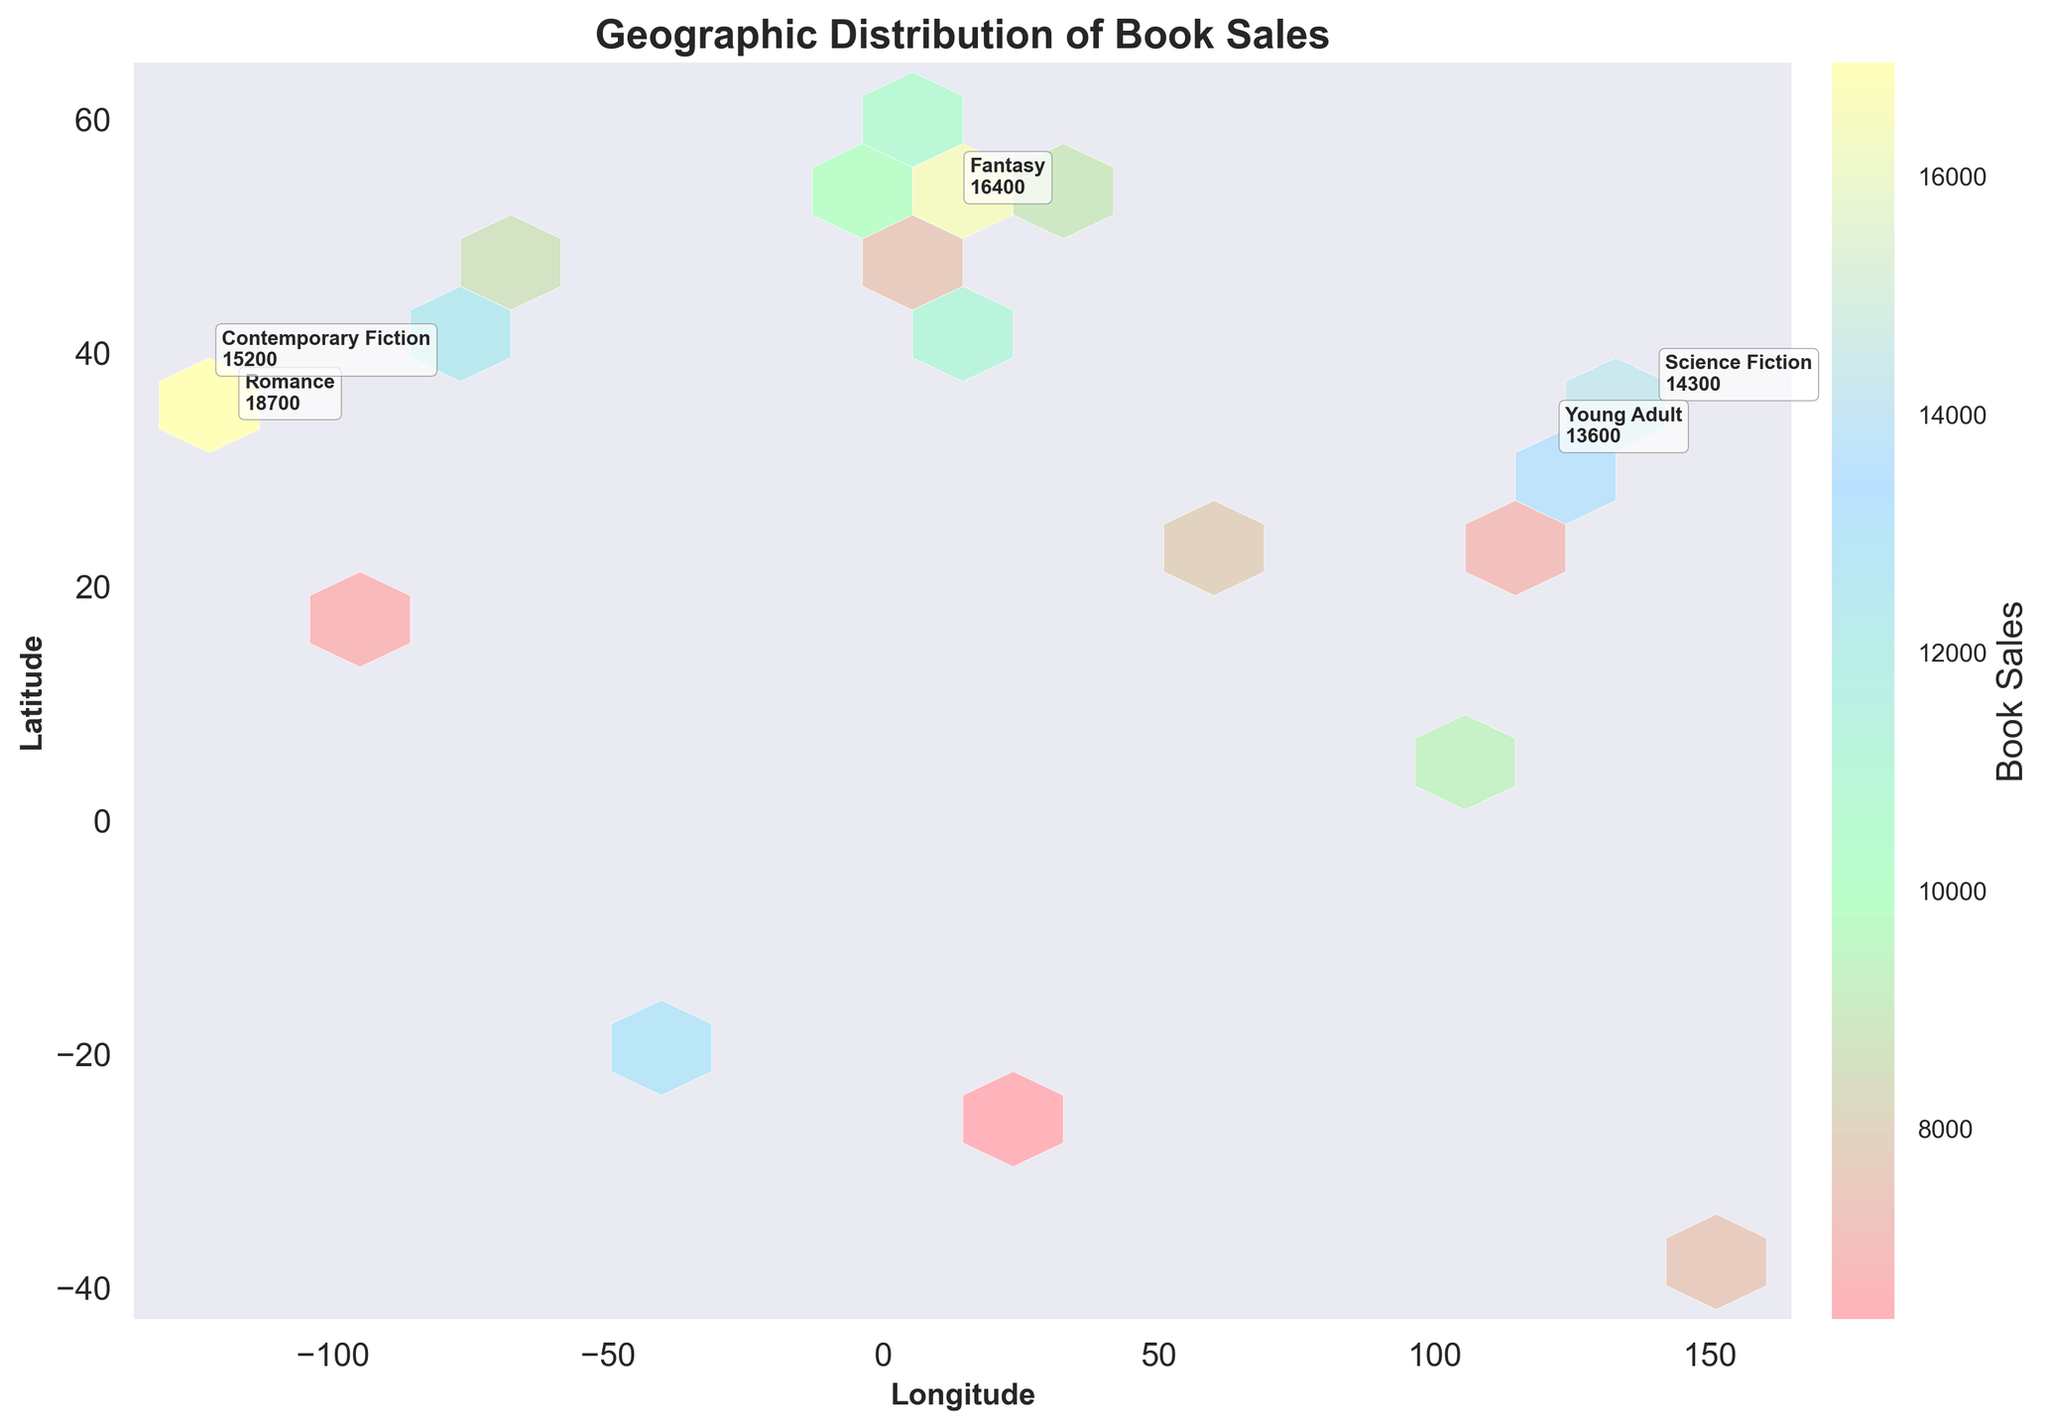1. What is the title of the plot? The title is usually found at the top of the plot, summarizing its content.
Answer: Geographic Distribution of Book Sales 2. How are the axes labeled? The x-axis and y-axis labels are "Longitude" and "Latitude," respectively, indicating the geographical coordinates of the data points.
Answer: Longitude, Latitude 3. How many genres are annotated in the plot? There are 5 data points that are highlighted with text annotations, usually shown with a label next to the data points.
Answer: 5 4. Which genre has the highest book sales, and what are those sales? By looking at the text annotations, find the one with the highest sales value. The highest value is typically the one with the largest number.
Answer: Romance, 18700 5. Which city has the coordinates closest to (40, -74) and what genre is popular there? Identify the annotations closest to the given coordinates and read the corresponding genre. 40.7128° N, 74.0060° W closely matches New York City, which has a Mystery genre.
Answer: Mystery 6. What is the color indicating the highest book sale on the color bar? Look at the color bar, which shows the gradient associated with the value of book sales. The color at the top end of the gradient represents the highest sales.
Answer: Pink 7. Compare the book sales of Science Fiction and Thriller. Which one has higher sales? Refer to the text annotations for Science Fiction (in Tokyo) and Thriller (in Rome). Compare their sales values.
Answer: Science Fiction 8. What's the combined book sales for the top 2 genres? The top 2 sales values are 18700 (Romance) and 16400 (Fantasy). Sum these values. 18700 + 16400 = 35100
Answer: 35100 9. What is the difference in book sales between Historical Fiction and Poetry? Find the sales values of both genres, Historical Fiction (9800) and Poetry (5200). Subtract the smaller value from the larger one to find the difference. 9800 - 5200 = 4600
Answer: 4600 10. How does book sales distribution look geographically around longitudes -74 and -118? Look at the hexagons close to these longitudes and observe the color intensity, which represents sales volume. New York (Longitude -74) and Los Angeles (Longitude -118) have relatively high sales, indicated by higher color intensities.
Answer: High sales distribution 